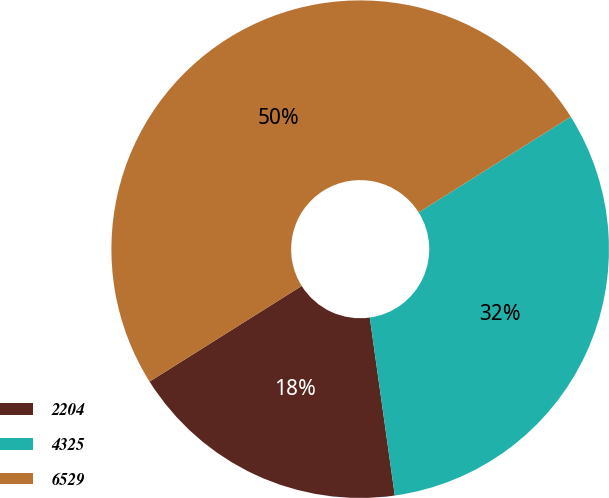Convert chart. <chart><loc_0><loc_0><loc_500><loc_500><pie_chart><fcel>2204<fcel>4325<fcel>6529<nl><fcel>18.29%<fcel>31.71%<fcel>50.0%<nl></chart> 